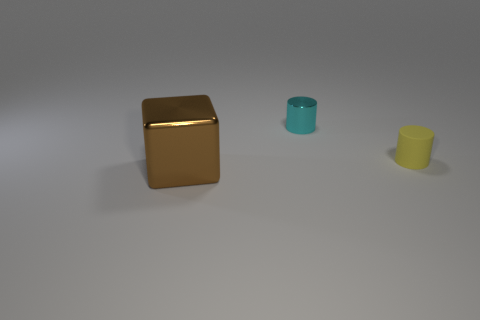Is there any other thing that is the same size as the brown shiny cube?
Your answer should be compact. No. Is there another big shiny thing of the same shape as the big metal thing?
Provide a short and direct response. No. What is the shape of the cyan thing?
Make the answer very short. Cylinder. What material is the thing that is behind the cylinder that is in front of the object behind the yellow rubber cylinder?
Your answer should be compact. Metal. Is the number of rubber cylinders to the right of the small yellow matte object greater than the number of large green matte cubes?
Provide a succinct answer. No. What material is the other cylinder that is the same size as the matte cylinder?
Provide a succinct answer. Metal. Is there a yellow object of the same size as the brown thing?
Your answer should be compact. No. What size is the metal thing that is behind the small yellow matte thing?
Provide a succinct answer. Small. What size is the rubber cylinder?
Keep it short and to the point. Small. How many balls are tiny metallic things or metallic objects?
Provide a short and direct response. 0. 